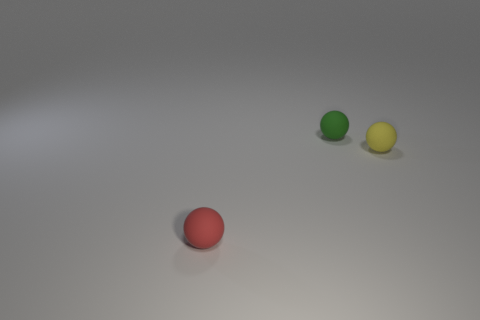Subtract all purple spheres. Subtract all gray blocks. How many spheres are left? 3 Add 2 green rubber objects. How many objects exist? 5 Add 3 tiny cylinders. How many tiny cylinders exist? 3 Subtract 0 gray cylinders. How many objects are left? 3 Subtract all small yellow matte objects. Subtract all green things. How many objects are left? 1 Add 1 rubber things. How many rubber things are left? 4 